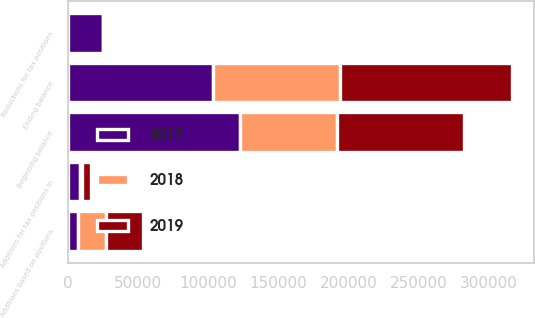<chart> <loc_0><loc_0><loc_500><loc_500><stacked_bar_chart><ecel><fcel>Beginning balance<fcel>Additions based on positions<fcel>Additions for tax positions in<fcel>Reductions for tax positions<fcel>Ending balance<nl><fcel>2017<fcel>122823<fcel>7193<fcel>8369<fcel>24932<fcel>103178<nl><fcel>2019<fcel>90615<fcel>26431<fcel>5844<fcel>67<fcel>122823<nl><fcel>2018<fcel>69052<fcel>20036<fcel>1878<fcel>29<fcel>90615<nl></chart> 